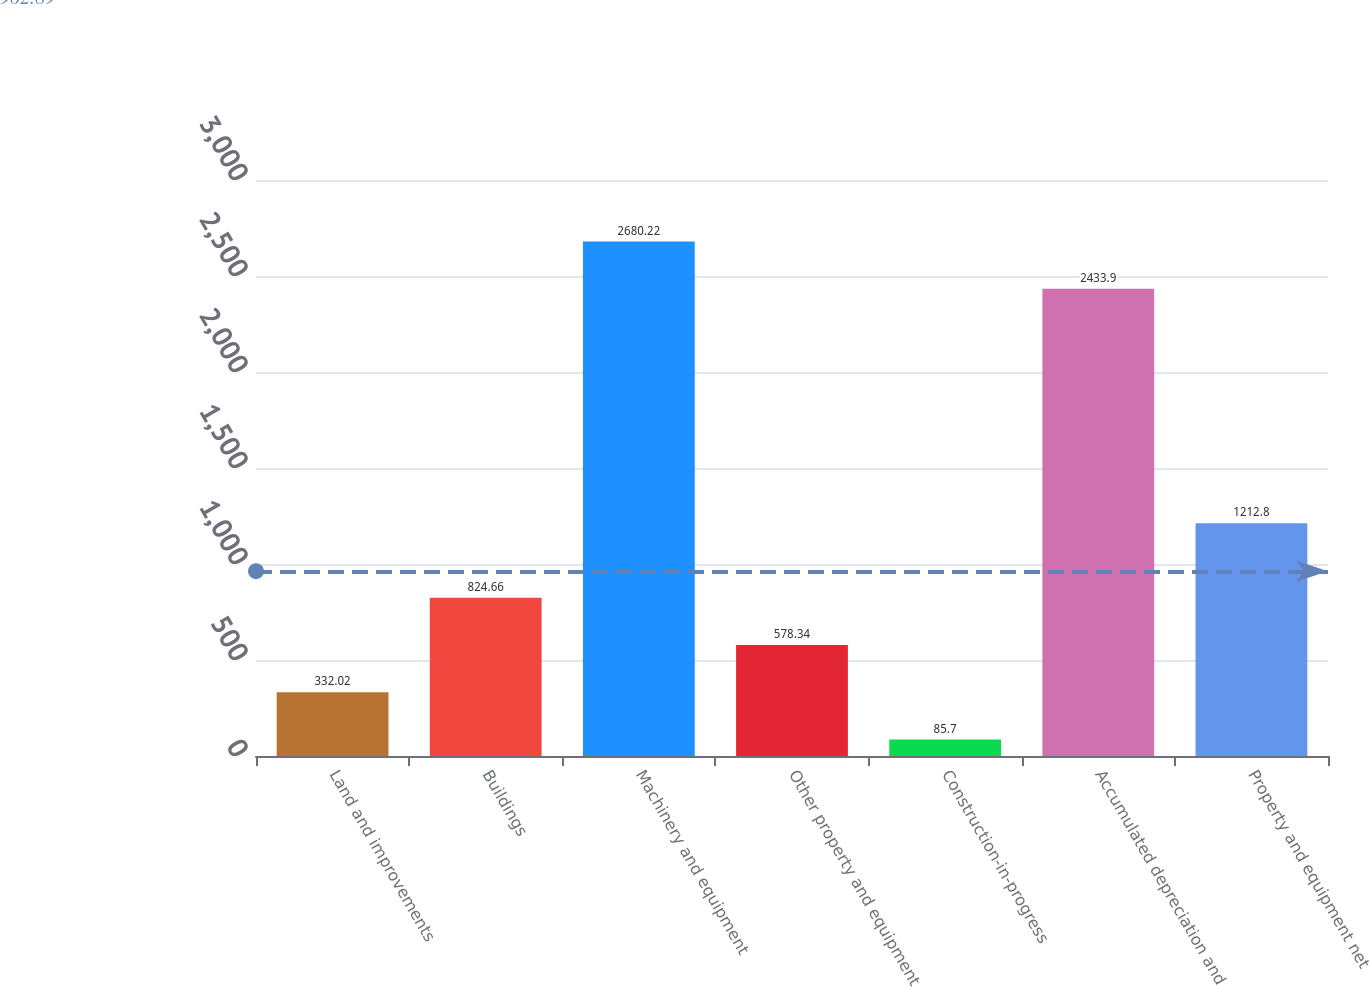Convert chart to OTSL. <chart><loc_0><loc_0><loc_500><loc_500><bar_chart><fcel>Land and improvements<fcel>Buildings<fcel>Machinery and equipment<fcel>Other property and equipment<fcel>Construction-in-progress<fcel>Accumulated depreciation and<fcel>Property and equipment net<nl><fcel>332.02<fcel>824.66<fcel>2680.22<fcel>578.34<fcel>85.7<fcel>2433.9<fcel>1212.8<nl></chart> 